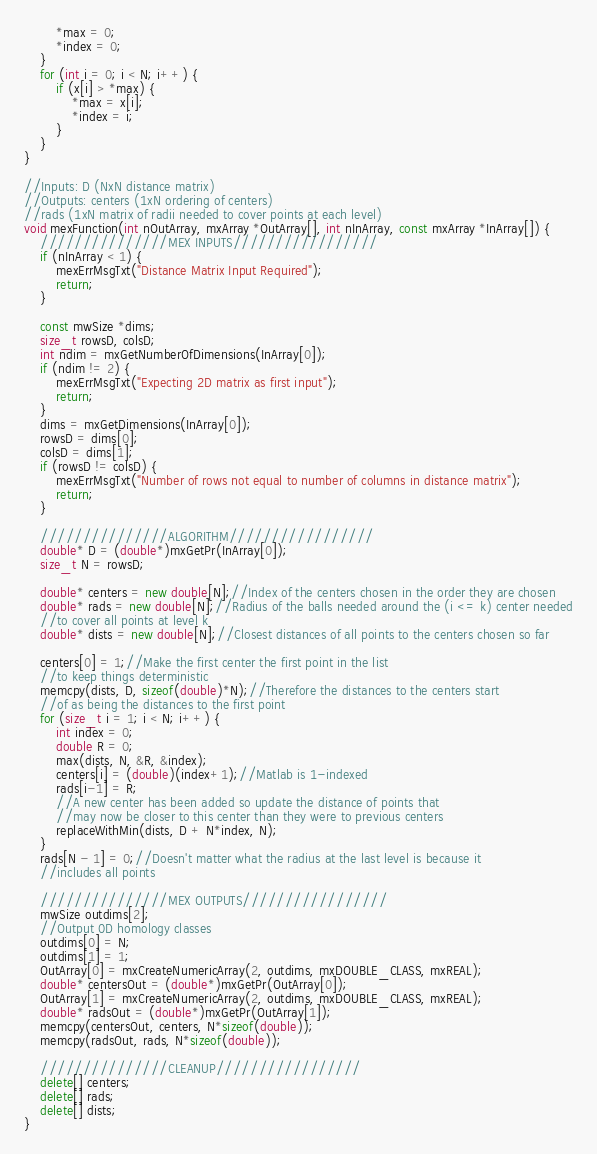Convert code to text. <code><loc_0><loc_0><loc_500><loc_500><_C++_>		*max = 0;
		*index = 0;
	}
	for (int i = 0; i < N; i++) {
		if (x[i] > *max) {
			*max = x[i];
			*index = i;
		}
	}
}

//Inputs: D (NxN distance matrix)
//Outputs: centers (1xN ordering of centers)
//rads (1xN matrix of radii needed to cover points at each level)
void mexFunction(int nOutArray, mxArray *OutArray[], int nInArray, const mxArray *InArray[]) {  
	///////////////MEX INPUTS/////////////////
	if (nInArray < 1) {
		mexErrMsgTxt("Distance Matrix Input Required");
		return;
	}
	
	const mwSize *dims;
	size_t rowsD, colsD;
	int ndim = mxGetNumberOfDimensions(InArray[0]);
	if (ndim != 2) {
		mexErrMsgTxt("Expecting 2D matrix as first input");
		return;
	}
	dims = mxGetDimensions(InArray[0]);
	rowsD = dims[0];
	colsD = dims[1];
	if (rowsD != colsD) {
		mexErrMsgTxt("Number of rows not equal to number of columns in distance matrix");
		return;
	}
	
	///////////////ALGORITHM/////////////////
	double* D = (double*)mxGetPr(InArray[0]);
	size_t N = rowsD;
	
	double* centers = new double[N];//Index of the centers chosen in the order they are chosen
	double* rads = new double[N];//Radius of the balls needed around the (i <= k) center needed
	//to cover all points at level k
	double* dists = new double[N];//Closest distances of all points to the centers chosen so far
	
	centers[0] = 1;//Make the first center the first point in the list
	//to keep things deterministic
	memcpy(dists, D, sizeof(double)*N);//Therefore the distances to the centers start
	//of as being the distances to the first point
	for (size_t i = 1; i < N; i++) {
		int index = 0;
		double R = 0;
		max(dists, N, &R, &index);
		centers[i] = (double)(index+1);//Matlab is 1-indexed
		rads[i-1] = R;
		//A new center has been added so update the distance of points that
		//may now be closer to this center than they were to previous centers
		replaceWithMin(dists, D + N*index, N);
	}
	rads[N - 1] = 0;//Doesn't matter what the radius at the last level is because it
	//includes all points
	
	///////////////MEX OUTPUTS/////////////////
	mwSize outdims[2];
	//Output 0D homology classes
	outdims[0] = N;
	outdims[1] = 1;
	OutArray[0] = mxCreateNumericArray(2, outdims, mxDOUBLE_CLASS, mxREAL);
	double* centersOut = (double*)mxGetPr(OutArray[0]);
	OutArray[1] = mxCreateNumericArray(2, outdims, mxDOUBLE_CLASS, mxREAL);
	double* radsOut = (double*)mxGetPr(OutArray[1]);
	memcpy(centersOut, centers, N*sizeof(double));
	memcpy(radsOut, rads, N*sizeof(double));
	
	///////////////CLEANUP/////////////////
	delete[] centers;
	delete[] rads;
	delete[] dists;
}
</code> 